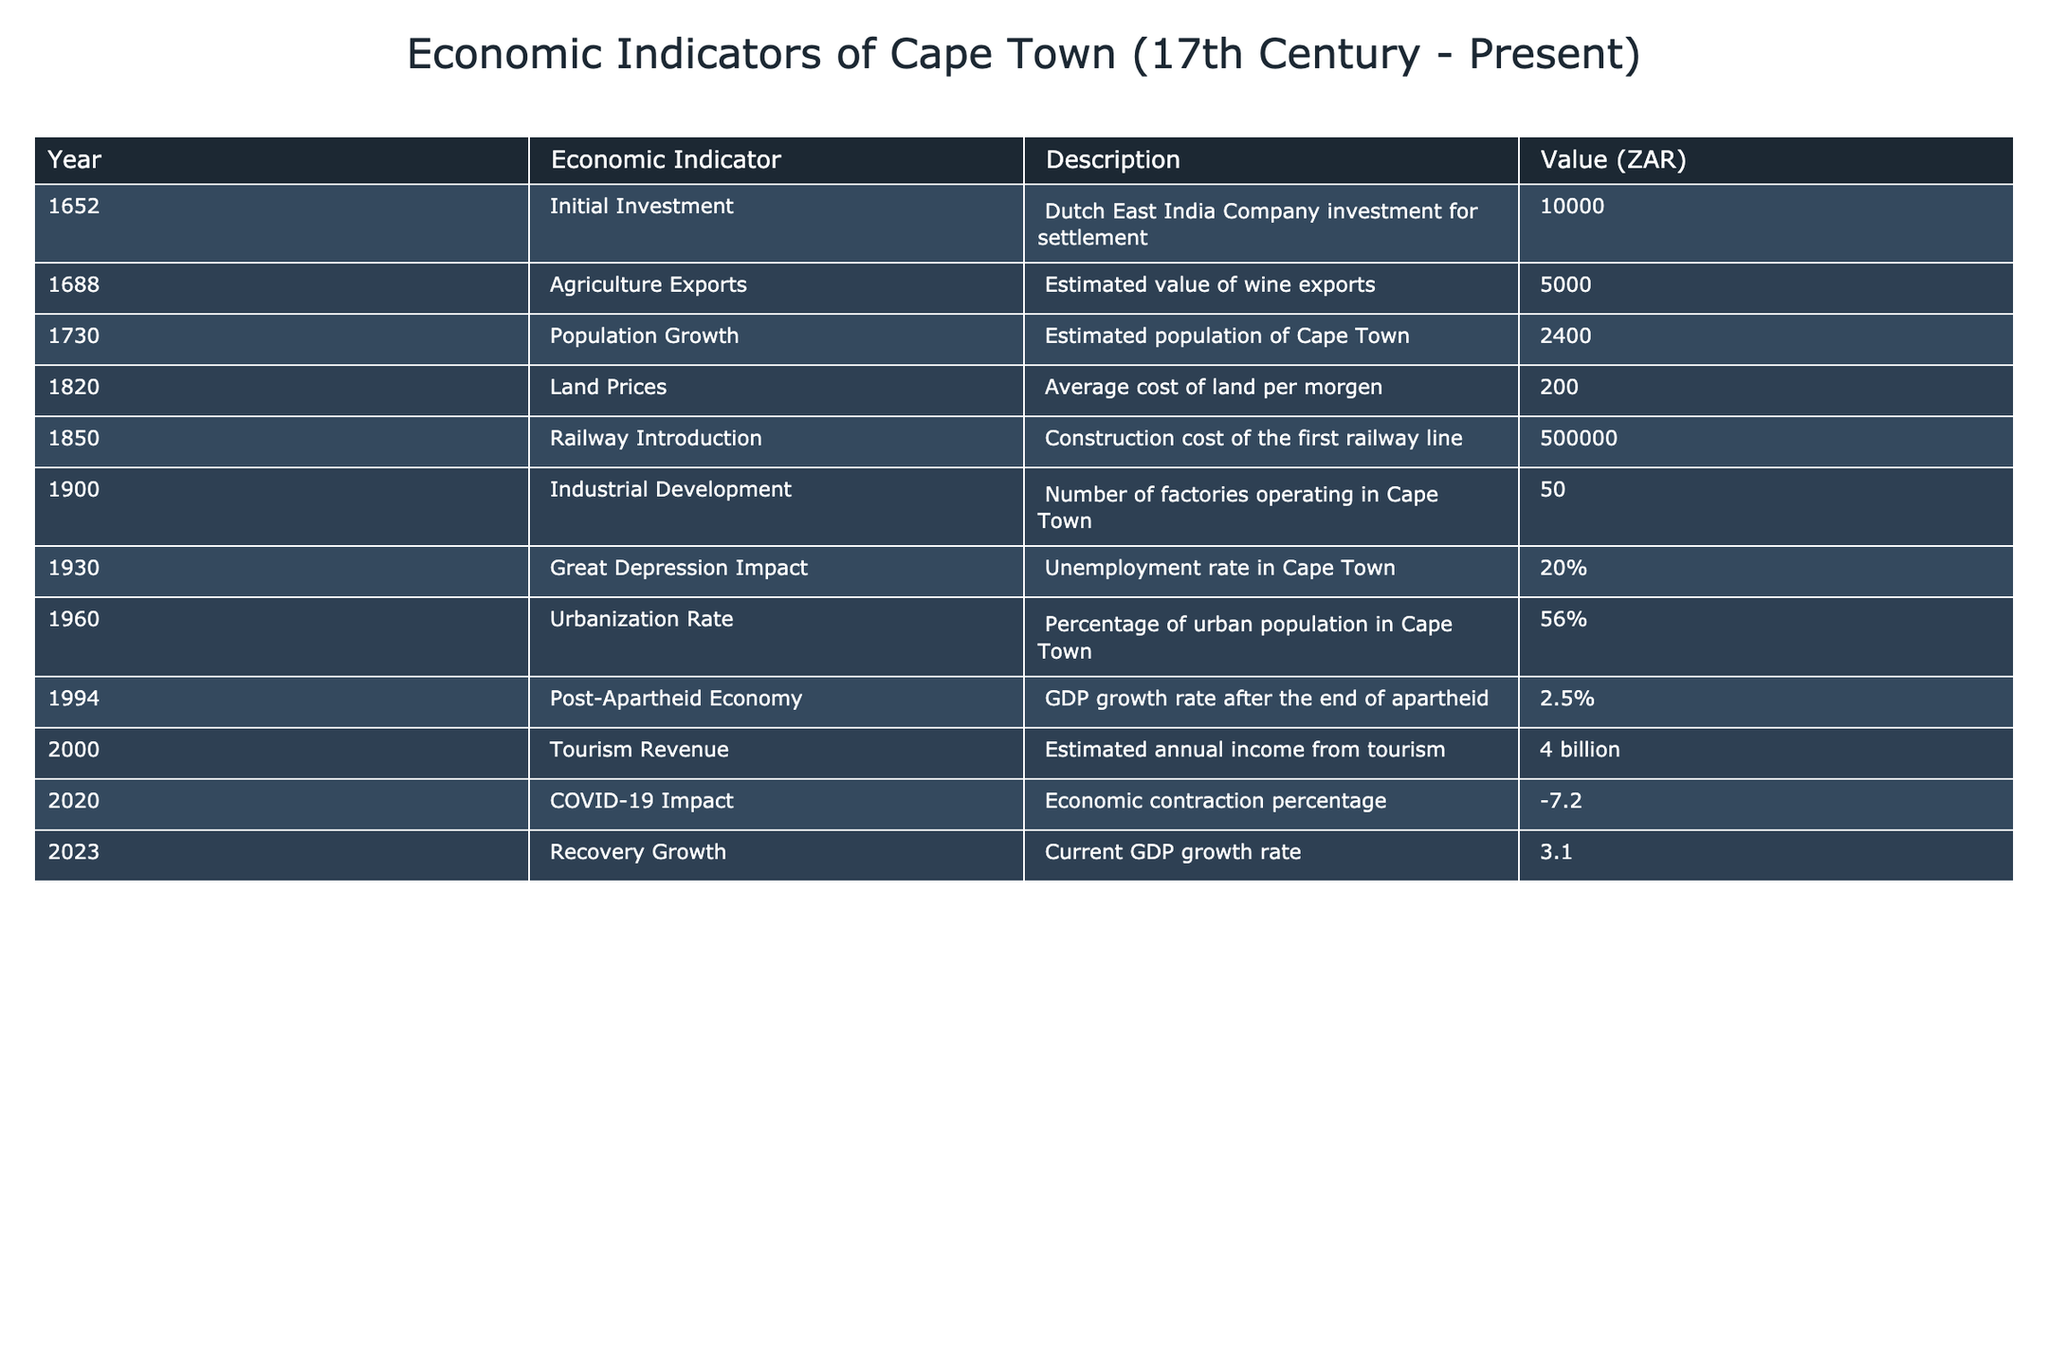What was the GDP growth rate in Cape Town in 1994? The table shows that in 1994, the GDP growth rate after the end of apartheid was 2.5%.
Answer: 2.5% What was the initial investment made by the Dutch East India Company in 1652? From the table, the initial investment is noted as 10,000 ZAR.
Answer: 10,000 ZAR What were the cumulative costs of significant infrastructure projects (Railway Introduction in 1850 and the first railway line)? The cost for the first railway line was 500,000 ZAR. Since no other infrastructure costs are mentioned, the cumulative cost remains 500,000 ZAR.
Answer: 500,000 ZAR Was the unemployment rate higher during the Great Depression in 1930 compared to the urbanization rate in 1960? The unemployment rate in 1930 was 20%, while the urbanization rate in 1960 was 56%. Since 20% is less than 56%, the unemployment rate was not higher.
Answer: No What is the difference in estimated value of agriculture exports in 1688 and tourism revenue in 2000? The agriculture exports in 1688 were 5,000 ZAR and the tourism revenue in 2000 was 4 billion ZAR, which is 4,000,000 ZAR. The difference is 4,000,000 - 5,000 = 3,995,000 ZAR.
Answer: 3,995,000 ZAR What was the unemployment rate reported in 1930? According to the table, the unemployment rate in Cape Town during the Great Depression in 1930 was 20%.
Answer: 20% Is Cape Town's current GDP growth rate in 2023 higher than its post-apartheid economy growth rate in 1994? The current GDP growth rate in 2023 is 3.1%, which is higher than the 2.5% growth rate in 1994. Therefore, the statement is true.
Answer: Yes What is the average value of the economic indicators recorded in the 17th century, from 1652 to 1730? The values for the 17th century indicators are 10,000 (1652) and 5,000 (1688) with 2,400 (1730). Summing these gives 10,000 + 5,000 + 2,400 = 17,400 ZAR, and dividing by 3 yields an average of 5,800 ZAR.
Answer: 5,800 ZAR How did COVID-19 impact the economy in Cape Town in 2020? The table indicates that in 2020, the economic contraction percentage was -7.2%. This reflects a downturn in the economy due to the pandemic.
Answer: -7.2% 